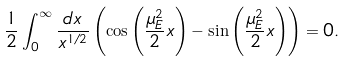<formula> <loc_0><loc_0><loc_500><loc_500>\frac { 1 } { 2 } \int ^ { \infty } _ { 0 } \frac { d x } { x ^ { 1 / 2 } } \left ( \cos \left ( \frac { \mu _ { E } ^ { 2 } } { 2 } x \right ) - \sin \left ( \frac { \mu _ { E } ^ { 2 } } { 2 } x \right ) \right ) = 0 .</formula> 